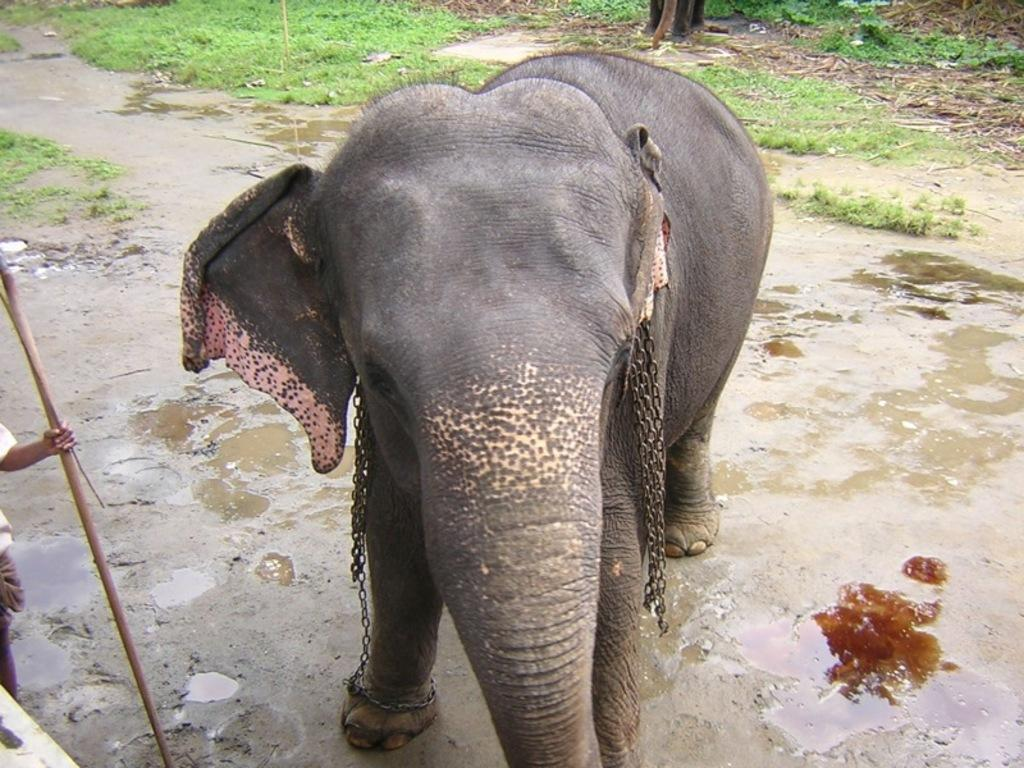What animal is present in the image? There is an elephant in the image. What is attached to the elephant? The elephant has iron chains. What is the person in the image holding? The person is holding a stick in the image. What type of terrain is visible in the image? Grass is visible on the ground in the image. What can be seen in addition to the grass? There is water visible in the image. What color is the ball being pointed at by the ray of light in the image? There is no ball or ray of light present in the image; it features an elephant with iron chains, a person holding a stick, grass, and water. 